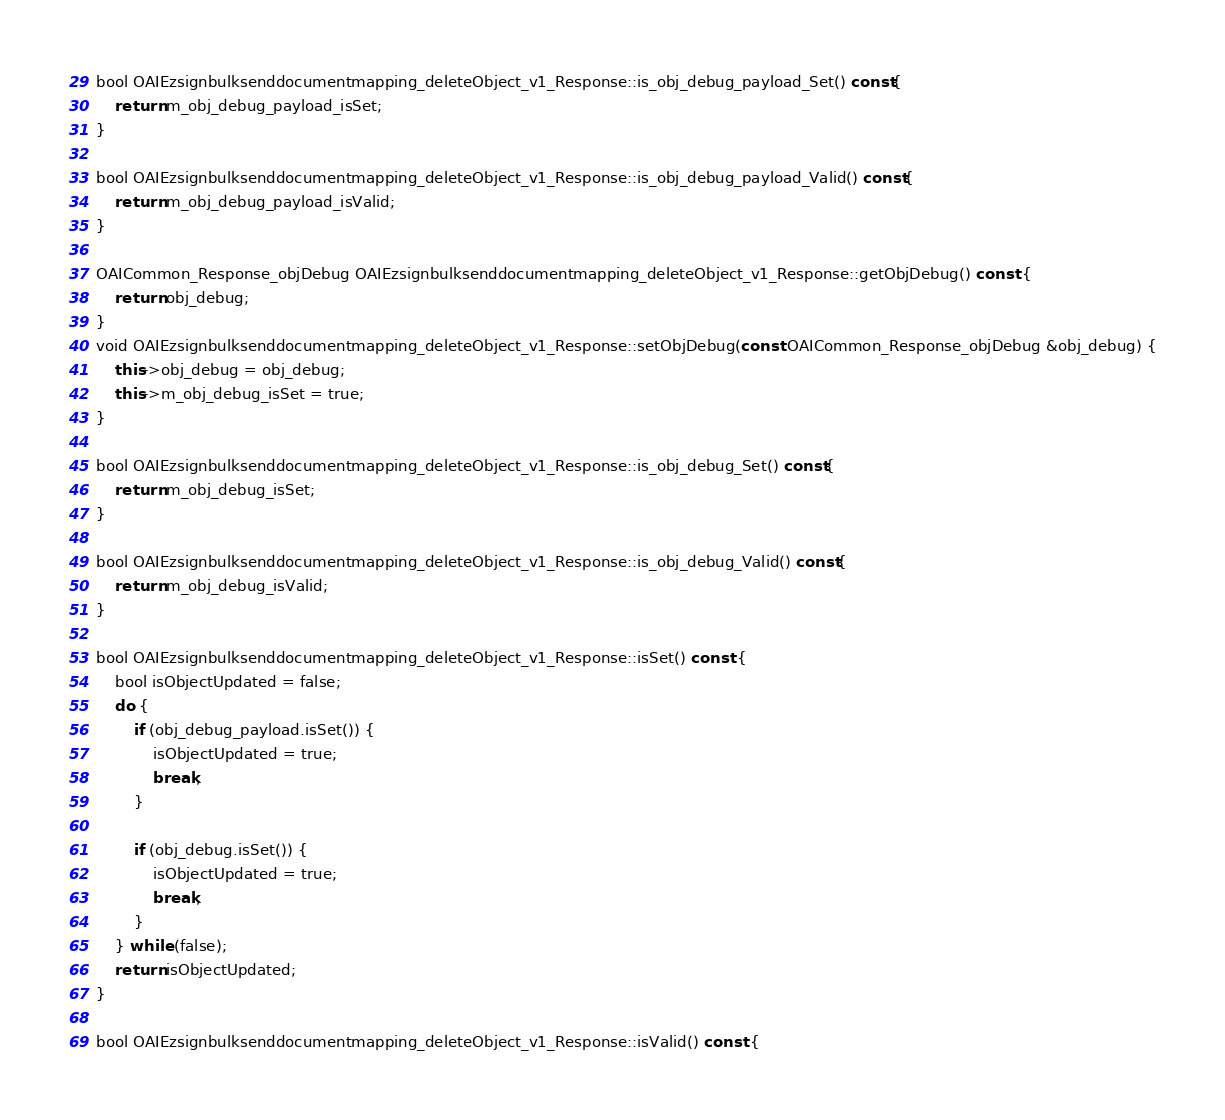<code> <loc_0><loc_0><loc_500><loc_500><_C++_>bool OAIEzsignbulksenddocumentmapping_deleteObject_v1_Response::is_obj_debug_payload_Set() const{
    return m_obj_debug_payload_isSet;
}

bool OAIEzsignbulksenddocumentmapping_deleteObject_v1_Response::is_obj_debug_payload_Valid() const{
    return m_obj_debug_payload_isValid;
}

OAICommon_Response_objDebug OAIEzsignbulksenddocumentmapping_deleteObject_v1_Response::getObjDebug() const {
    return obj_debug;
}
void OAIEzsignbulksenddocumentmapping_deleteObject_v1_Response::setObjDebug(const OAICommon_Response_objDebug &obj_debug) {
    this->obj_debug = obj_debug;
    this->m_obj_debug_isSet = true;
}

bool OAIEzsignbulksenddocumentmapping_deleteObject_v1_Response::is_obj_debug_Set() const{
    return m_obj_debug_isSet;
}

bool OAIEzsignbulksenddocumentmapping_deleteObject_v1_Response::is_obj_debug_Valid() const{
    return m_obj_debug_isValid;
}

bool OAIEzsignbulksenddocumentmapping_deleteObject_v1_Response::isSet() const {
    bool isObjectUpdated = false;
    do {
        if (obj_debug_payload.isSet()) {
            isObjectUpdated = true;
            break;
        }

        if (obj_debug.isSet()) {
            isObjectUpdated = true;
            break;
        }
    } while (false);
    return isObjectUpdated;
}

bool OAIEzsignbulksenddocumentmapping_deleteObject_v1_Response::isValid() const {</code> 